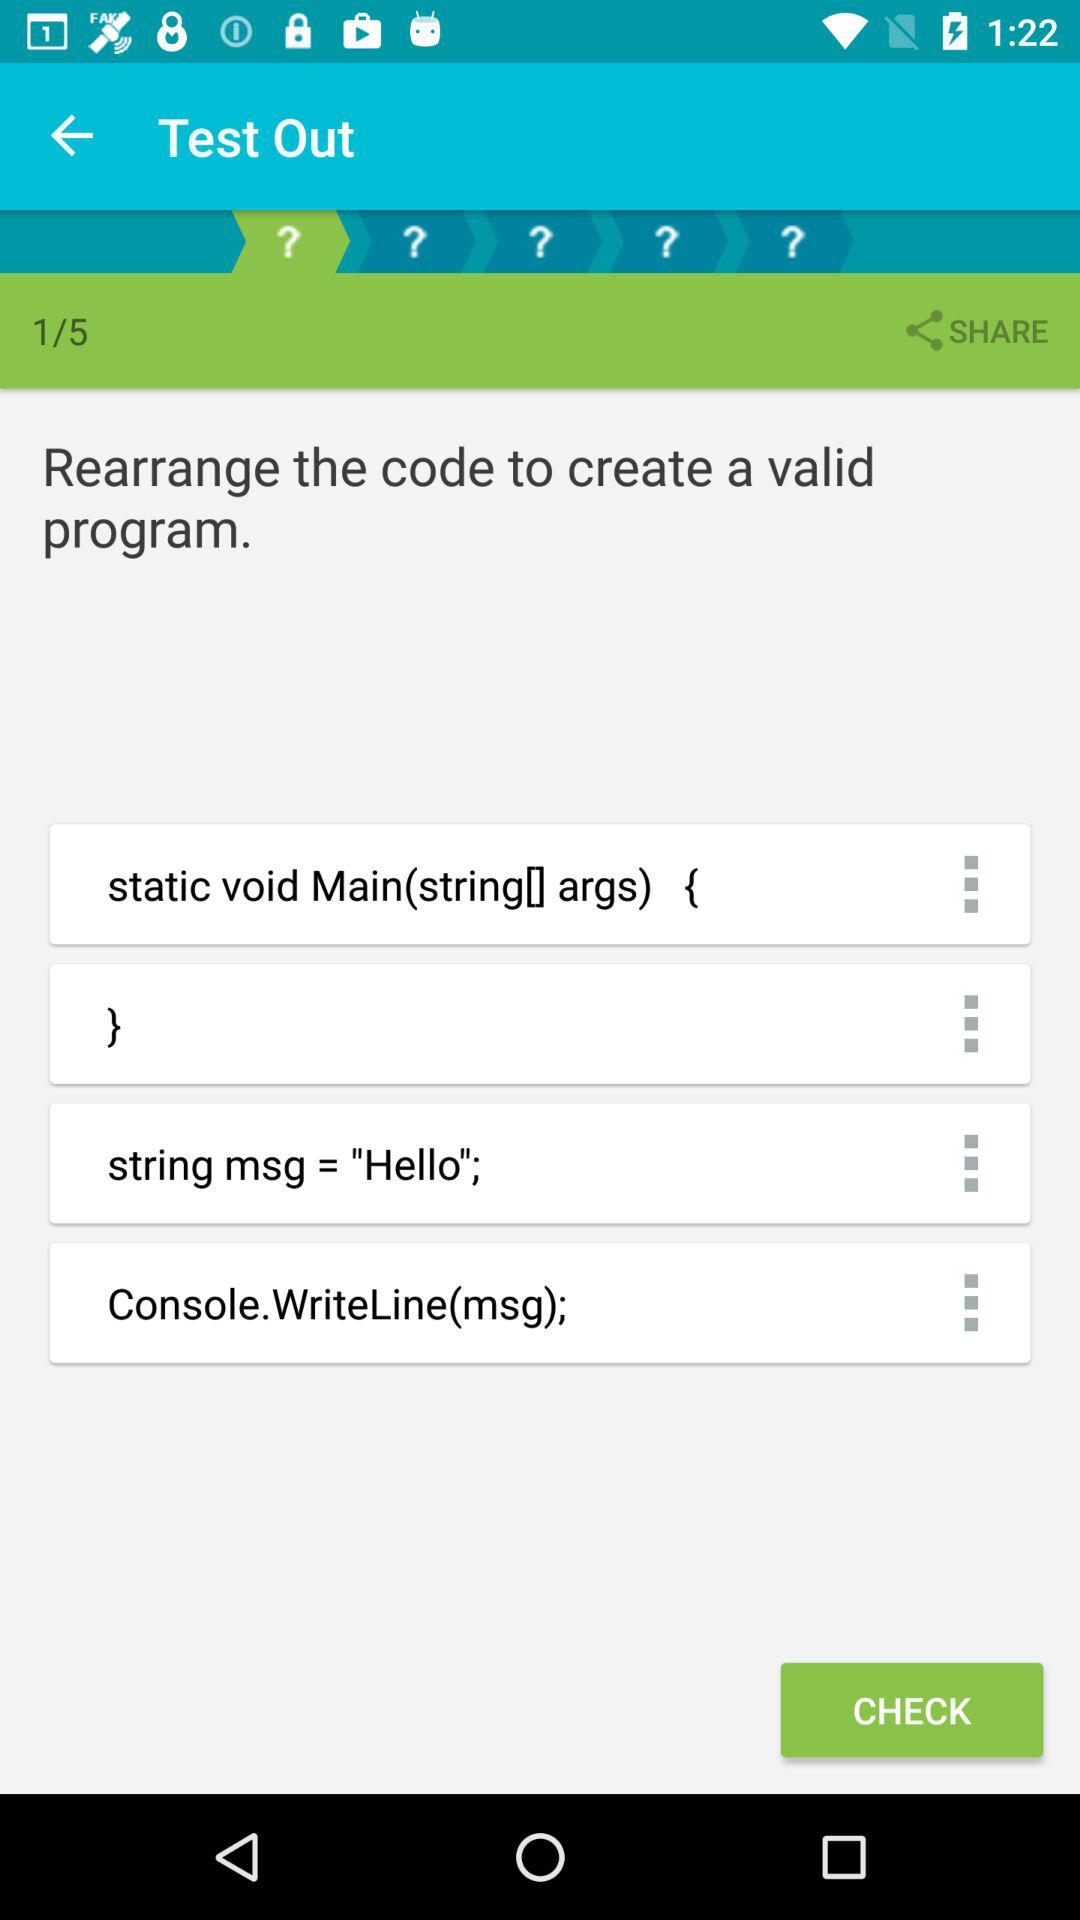How many lines of code are there in this code block?
Answer the question using a single word or phrase. 4 